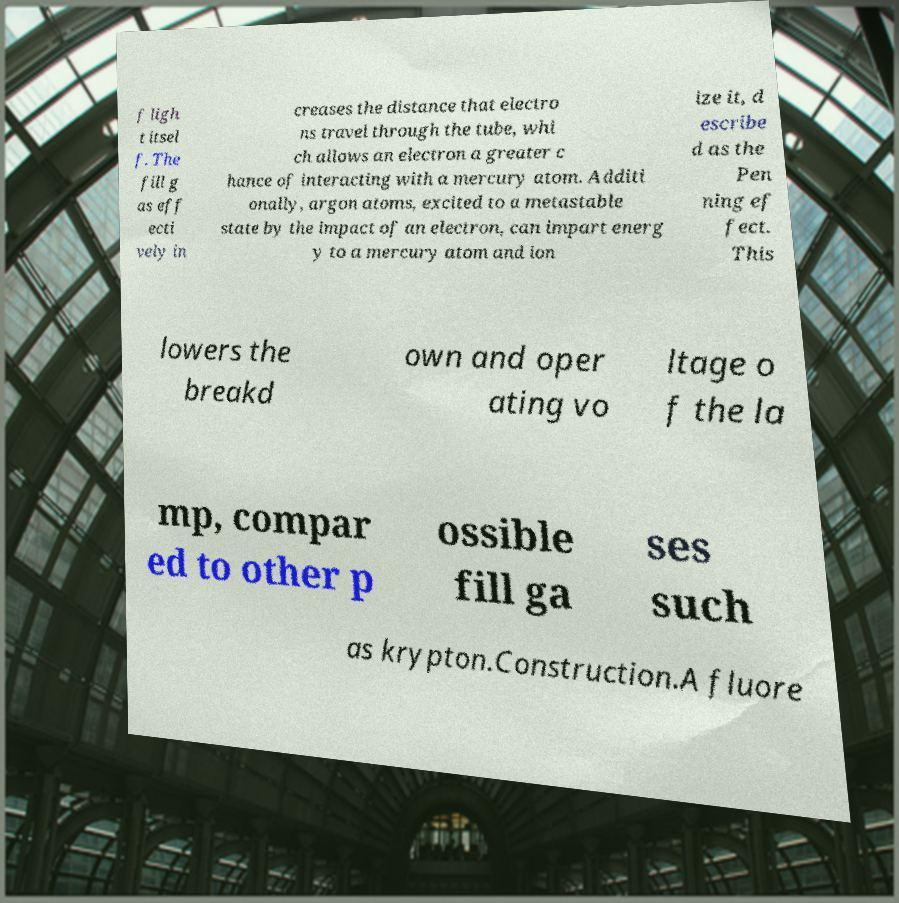Could you extract and type out the text from this image? f ligh t itsel f. The fill g as eff ecti vely in creases the distance that electro ns travel through the tube, whi ch allows an electron a greater c hance of interacting with a mercury atom. Additi onally, argon atoms, excited to a metastable state by the impact of an electron, can impart energ y to a mercury atom and ion ize it, d escribe d as the Pen ning ef fect. This lowers the breakd own and oper ating vo ltage o f the la mp, compar ed to other p ossible fill ga ses such as krypton.Construction.A fluore 